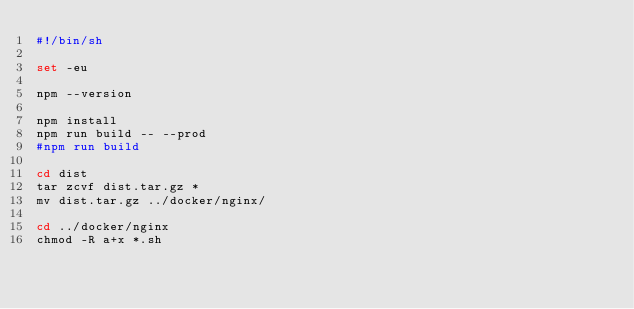<code> <loc_0><loc_0><loc_500><loc_500><_Bash_>#!/bin/sh

set -eu

npm --version

npm install
npm run build -- --prod
#npm run build

cd dist
tar zcvf dist.tar.gz *
mv dist.tar.gz ../docker/nginx/

cd ../docker/nginx
chmod -R a+x *.sh
</code> 